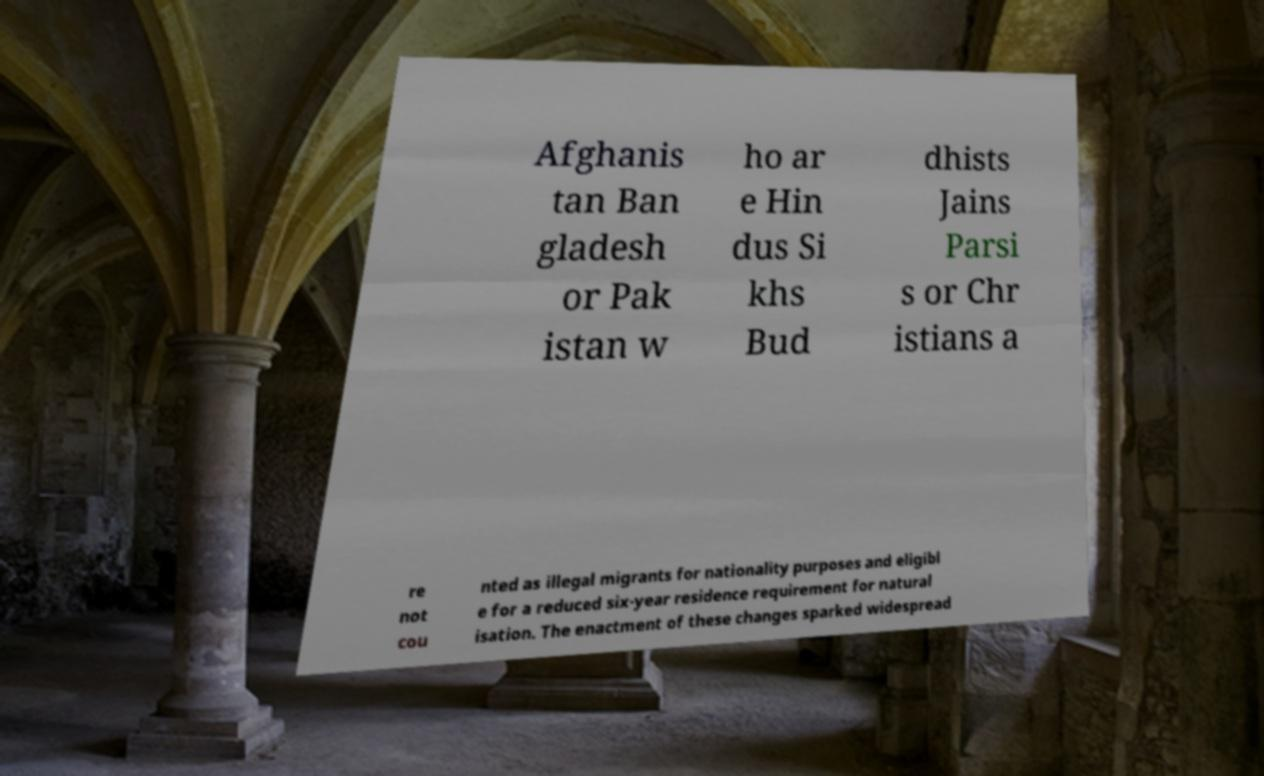Could you assist in decoding the text presented in this image and type it out clearly? Afghanis tan Ban gladesh or Pak istan w ho ar e Hin dus Si khs Bud dhists Jains Parsi s or Chr istians a re not cou nted as illegal migrants for nationality purposes and eligibl e for a reduced six-year residence requirement for natural isation. The enactment of these changes sparked widespread 